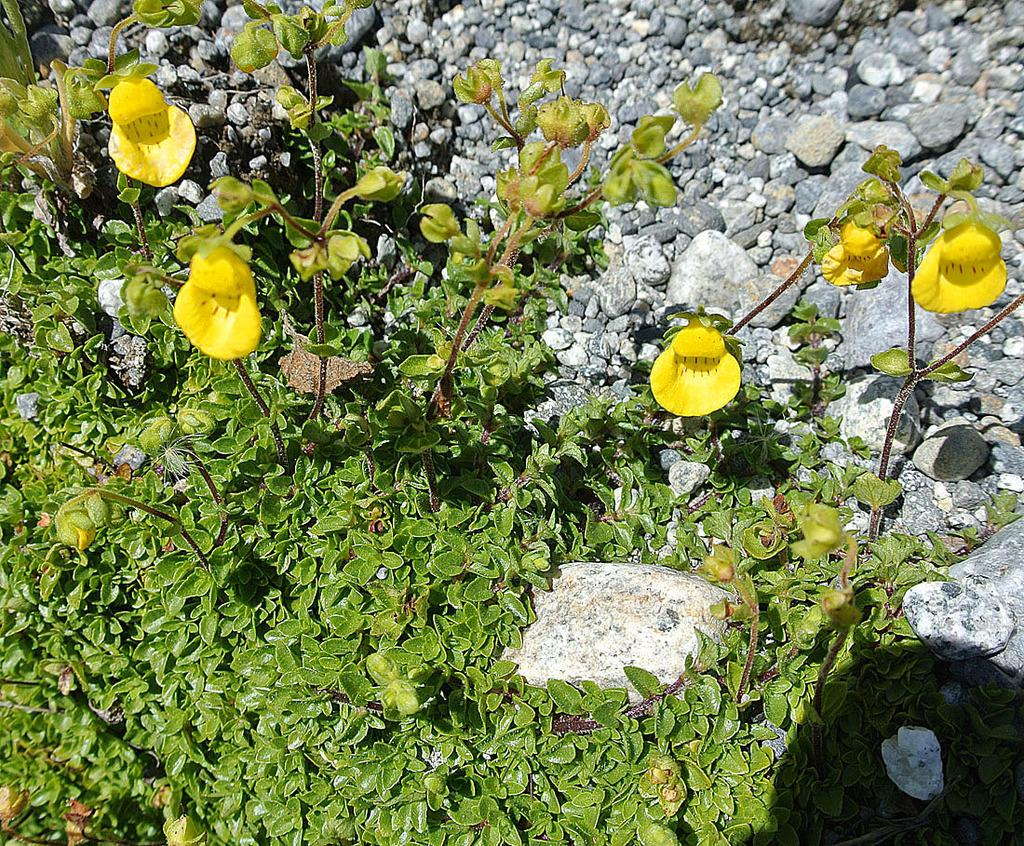What type of living organisms can be seen in the image? Plants can be seen in the image. What type of inanimate objects are present in the image? Stones are present in the image. How many fingers can be seen on the boy in the image? There is no boy present in the image, so it is not possible to determine the number of fingers visible. 